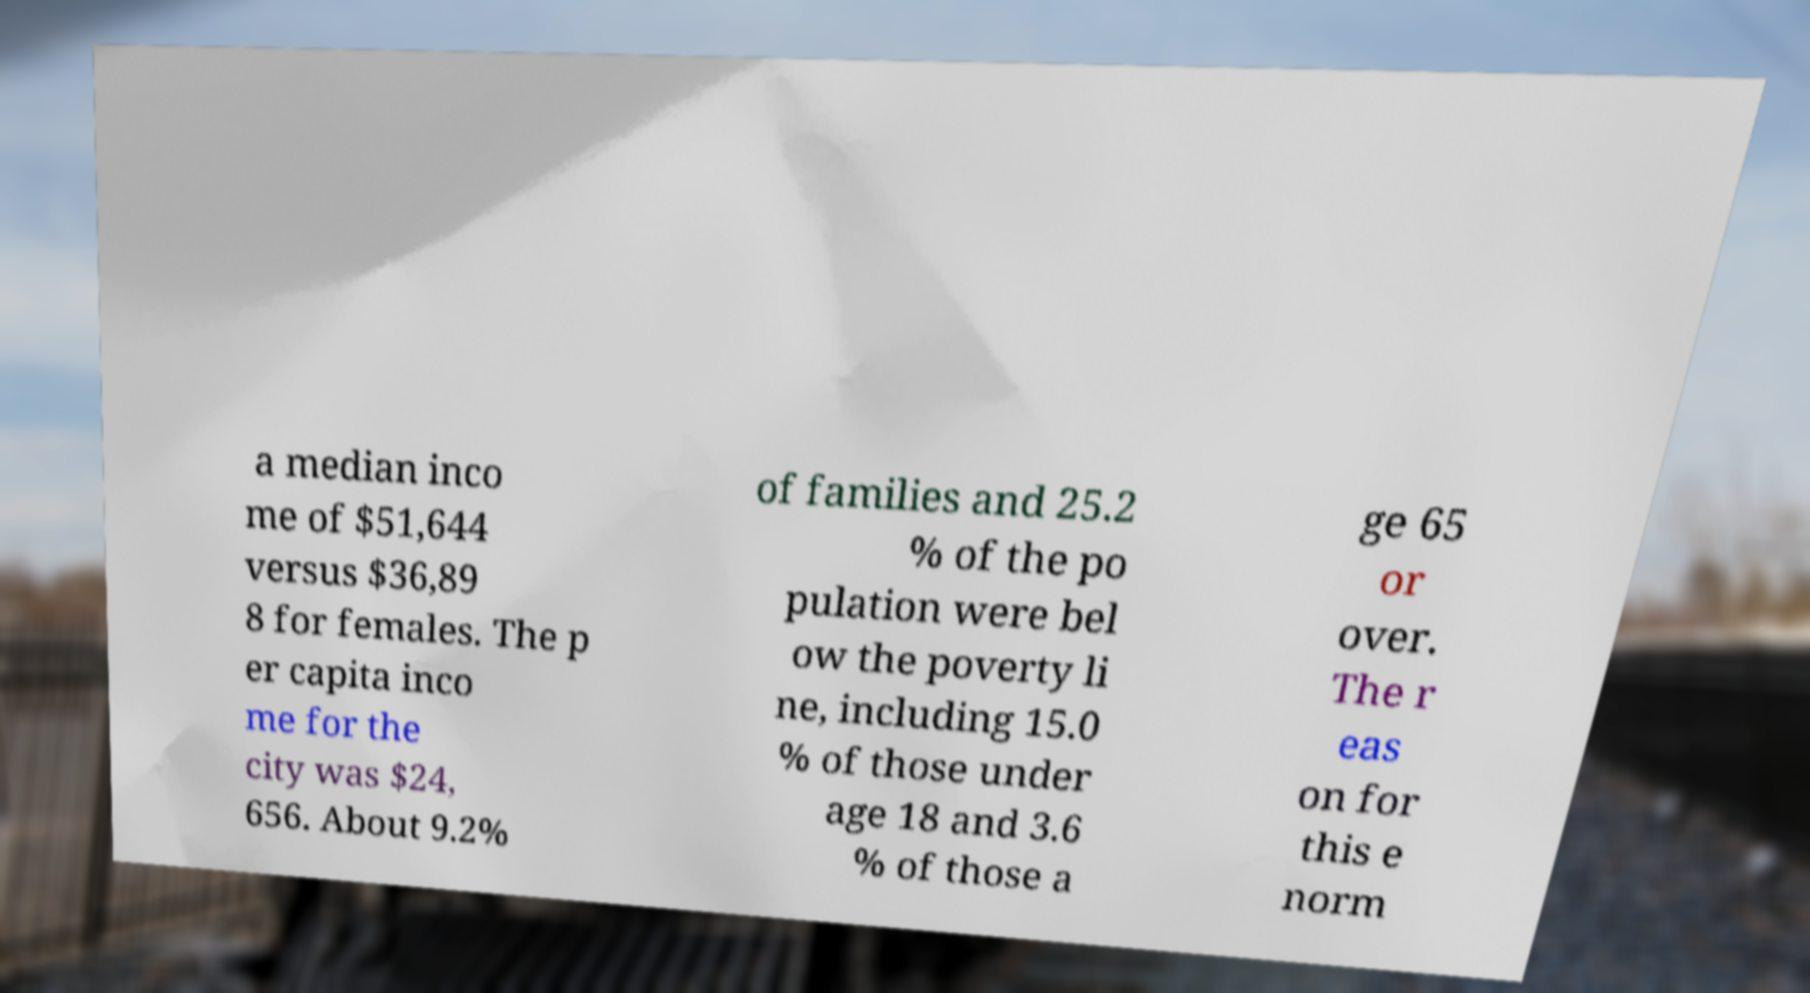Please identify and transcribe the text found in this image. a median inco me of $51,644 versus $36,89 8 for females. The p er capita inco me for the city was $24, 656. About 9.2% of families and 25.2 % of the po pulation were bel ow the poverty li ne, including 15.0 % of those under age 18 and 3.6 % of those a ge 65 or over. The r eas on for this e norm 